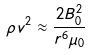Convert formula to latex. <formula><loc_0><loc_0><loc_500><loc_500>\rho v ^ { 2 } \approx \frac { 2 B _ { 0 } ^ { 2 } } { r ^ { 6 } \mu _ { 0 } }</formula> 